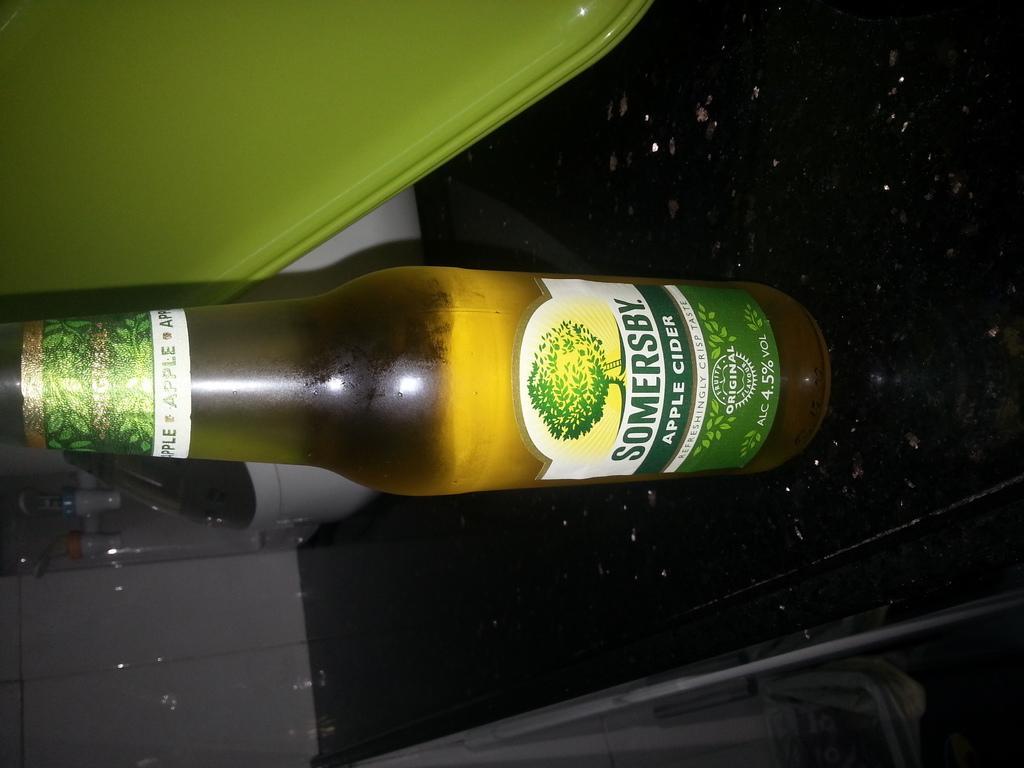Please provide a concise description of this image. In this image we can see a bottle with a drink on a surface. On the bottle we can see a label and on the label we can see the text and a logo. At the top we can see a green object. On the left side, we can see few objects. 